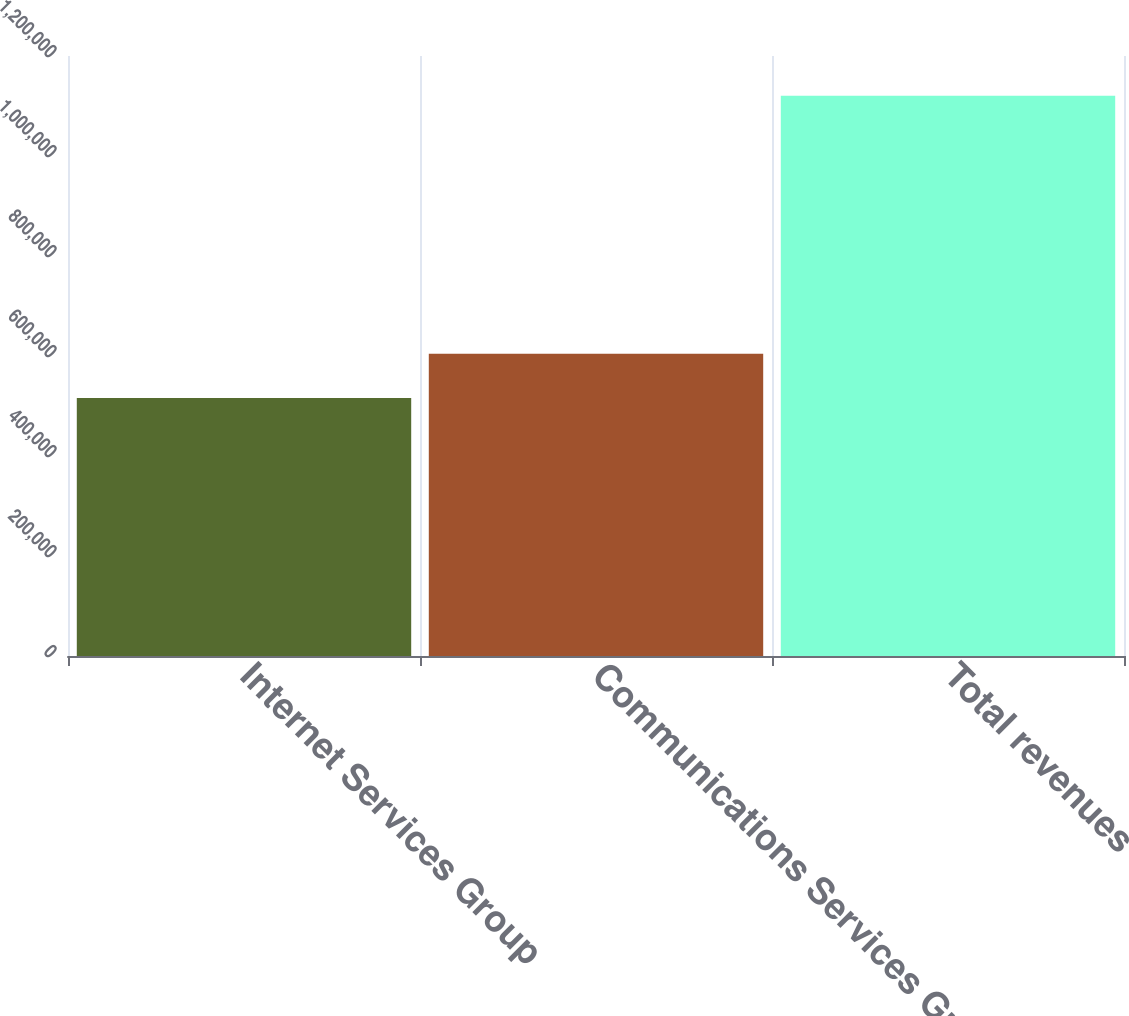Convert chart to OTSL. <chart><loc_0><loc_0><loc_500><loc_500><bar_chart><fcel>Internet Services Group<fcel>Communications Services Group<fcel>Total revenues<nl><fcel>515999<fcel>604596<fcel>1.1206e+06<nl></chart> 